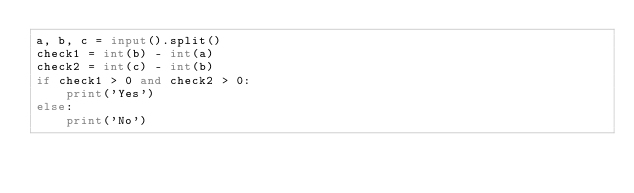<code> <loc_0><loc_0><loc_500><loc_500><_Python_>a, b, c = input().split()
check1 = int(b) - int(a)
check2 = int(c) - int(b)
if check1 > 0 and check2 > 0:
    print('Yes')
else:
    print('No')</code> 